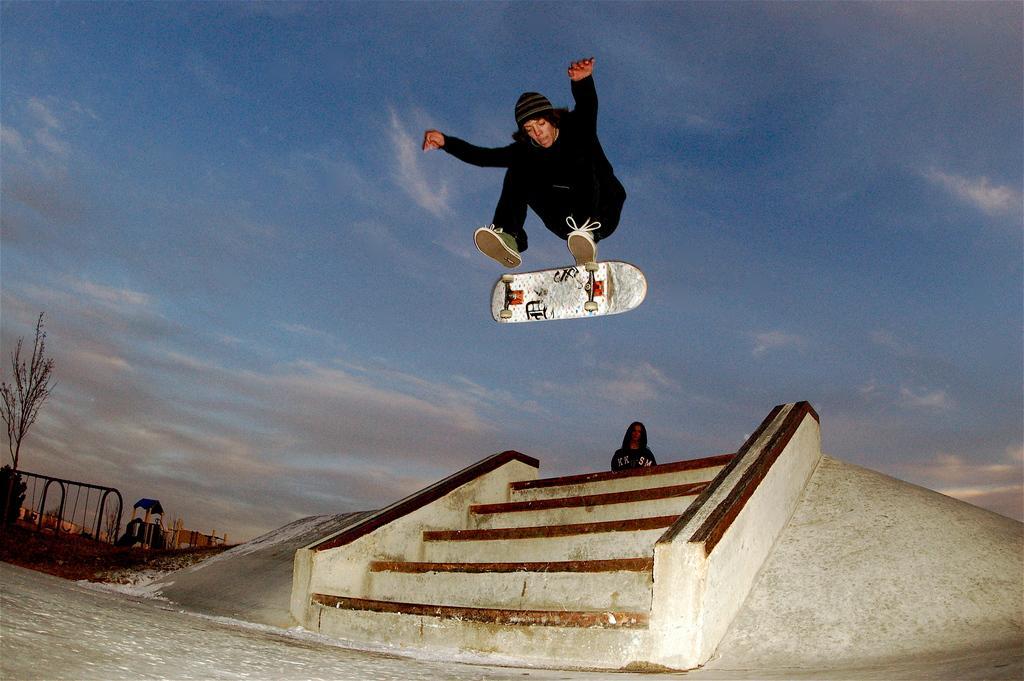How would you summarize this image in a sentence or two? In this image there is the sky towards the top of the image, there are clouds in the sky, there is a woman standing, there is a man jumping, he is wearing a cap, there is a skating board, there are staircases, there is ground towards the bottom of the image, there is a tree towards the left of the image, there are objects towards the left of the image. 